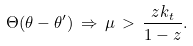<formula> <loc_0><loc_0><loc_500><loc_500>\Theta ( \theta - \theta ^ { \prime } ) \, \Rightarrow \, \mu \, > \, \frac { z k _ { t } } { 1 - z } .</formula> 